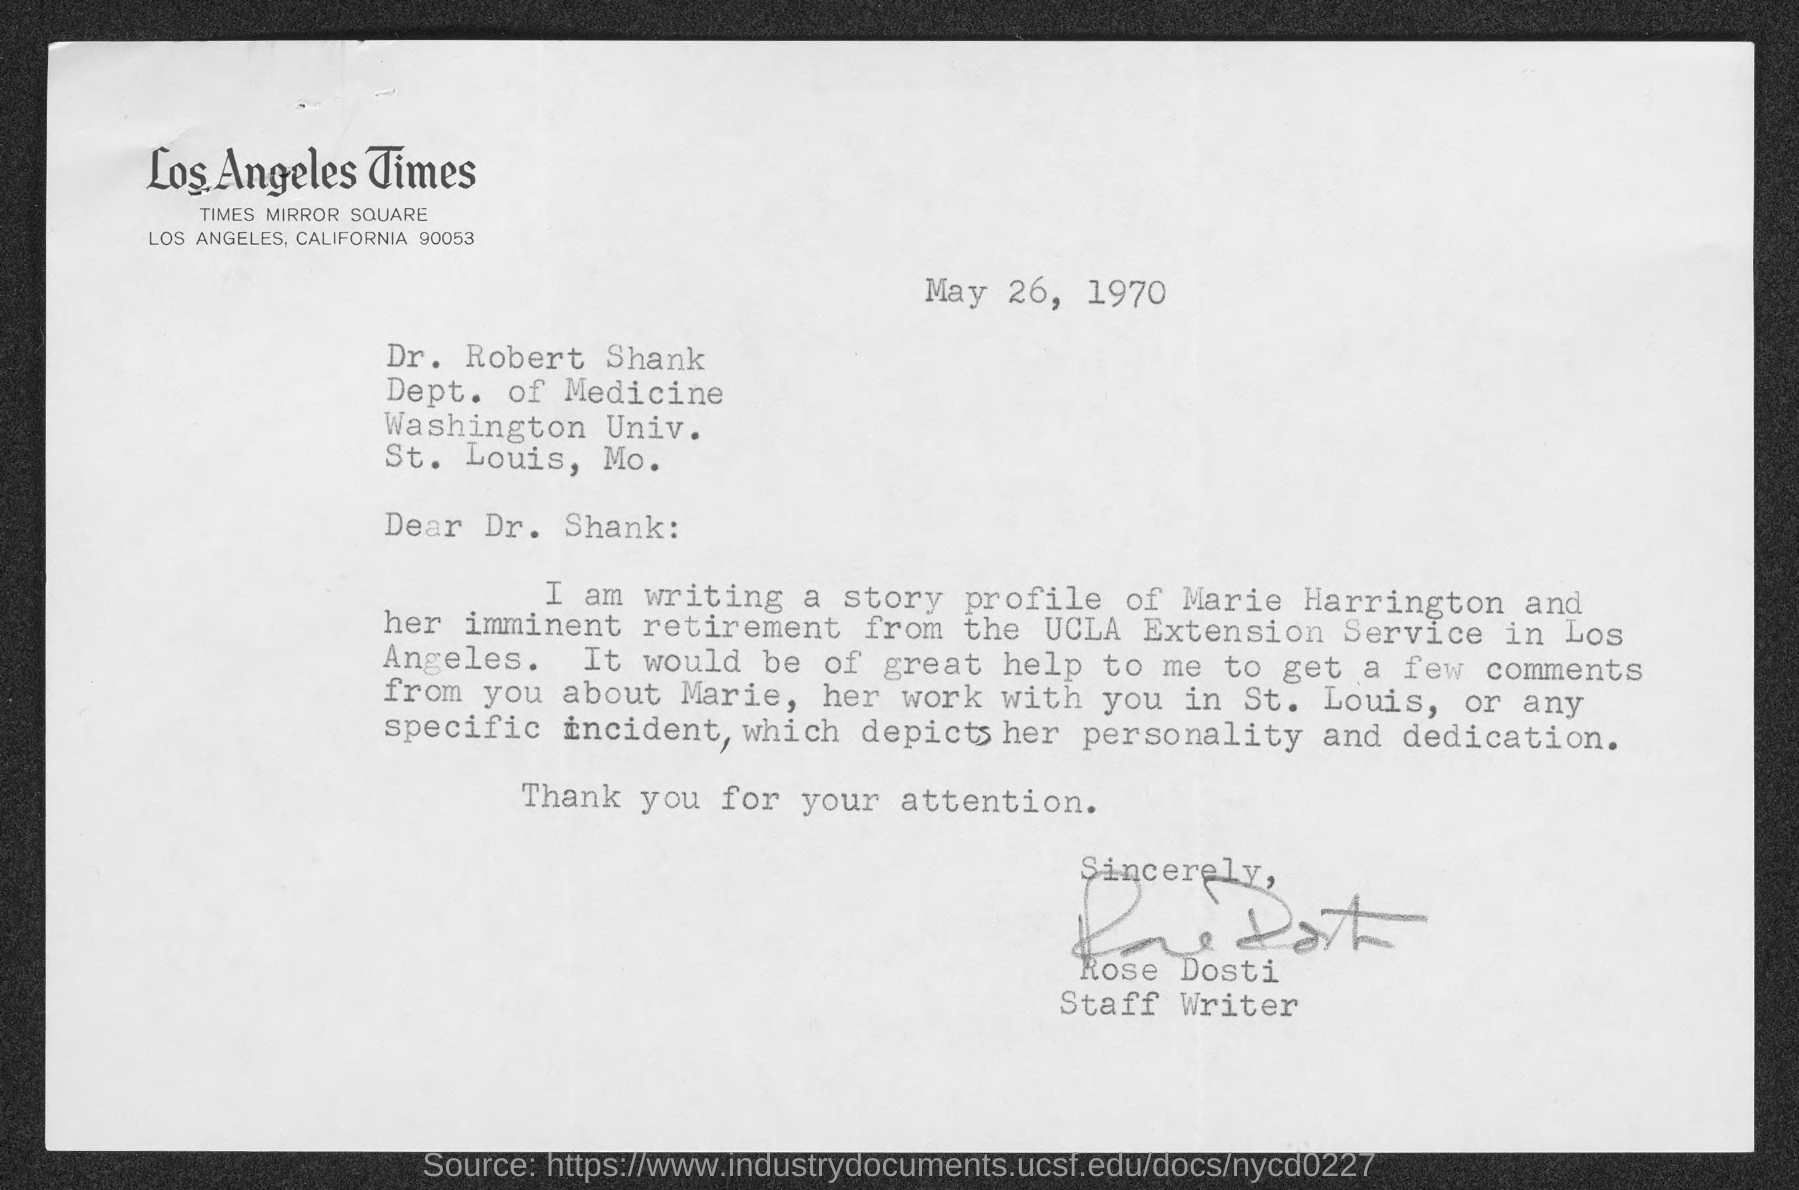Specify some key components in this picture. Dr. Robert Shank works in the Department of Medicine. The Los Angeles Times is mentioned in the letterhead of the document. The date mentioned in this letter is May 26, 1970. The letter has been signed by Rose Dosti. Rose Dosti holds the designation of Staff Writer. 